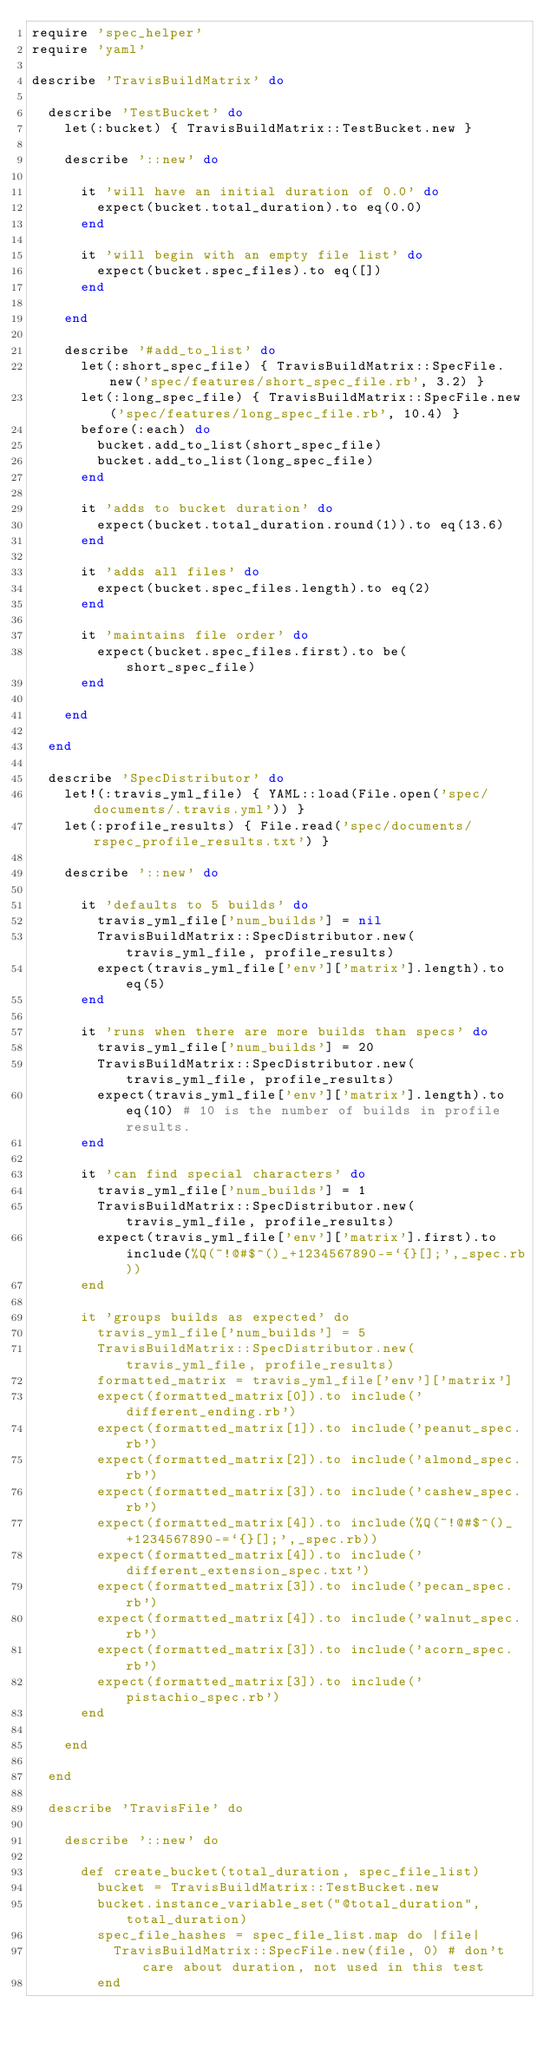<code> <loc_0><loc_0><loc_500><loc_500><_Ruby_>require 'spec_helper'
require 'yaml'

describe 'TravisBuildMatrix' do

  describe 'TestBucket' do
    let(:bucket) { TravisBuildMatrix::TestBucket.new }

    describe '::new' do

      it 'will have an initial duration of 0.0' do
        expect(bucket.total_duration).to eq(0.0)
      end

      it 'will begin with an empty file list' do
        expect(bucket.spec_files).to eq([])
      end

    end

    describe '#add_to_list' do
      let(:short_spec_file) { TravisBuildMatrix::SpecFile.new('spec/features/short_spec_file.rb', 3.2) }
      let(:long_spec_file) { TravisBuildMatrix::SpecFile.new('spec/features/long_spec_file.rb', 10.4) }
      before(:each) do
        bucket.add_to_list(short_spec_file)
        bucket.add_to_list(long_spec_file)
      end

      it 'adds to bucket duration' do
        expect(bucket.total_duration.round(1)).to eq(13.6)
      end

      it 'adds all files' do
        expect(bucket.spec_files.length).to eq(2)
      end

      it 'maintains file order' do
        expect(bucket.spec_files.first).to be(short_spec_file)
      end

    end

  end

  describe 'SpecDistributor' do
    let!(:travis_yml_file) { YAML::load(File.open('spec/documents/.travis.yml')) }
    let(:profile_results) { File.read('spec/documents/rspec_profile_results.txt') }

    describe '::new' do

      it 'defaults to 5 builds' do
        travis_yml_file['num_builds'] = nil
        TravisBuildMatrix::SpecDistributor.new(travis_yml_file, profile_results)
        expect(travis_yml_file['env']['matrix'].length).to eq(5)
      end

      it 'runs when there are more builds than specs' do
        travis_yml_file['num_builds'] = 20
        TravisBuildMatrix::SpecDistributor.new(travis_yml_file, profile_results)
        expect(travis_yml_file['env']['matrix'].length).to eq(10) # 10 is the number of builds in profile results.
      end

      it 'can find special characters' do
        travis_yml_file['num_builds'] = 1
        TravisBuildMatrix::SpecDistributor.new(travis_yml_file, profile_results)
        expect(travis_yml_file['env']['matrix'].first).to include(%Q(~!@#$^()_+1234567890-=`{}[];',_spec.rb))
      end
      
      it 'groups builds as expected' do
        travis_yml_file['num_builds'] = 5
        TravisBuildMatrix::SpecDistributor.new(travis_yml_file, profile_results)
        formatted_matrix = travis_yml_file['env']['matrix']
        expect(formatted_matrix[0]).to include('different_ending.rb')
        expect(formatted_matrix[1]).to include('peanut_spec.rb')
        expect(formatted_matrix[2]).to include('almond_spec.rb')
        expect(formatted_matrix[3]).to include('cashew_spec.rb')
        expect(formatted_matrix[4]).to include(%Q(~!@#$^()_+1234567890-=`{}[];',_spec.rb))
        expect(formatted_matrix[4]).to include('different_extension_spec.txt')
        expect(formatted_matrix[3]).to include('pecan_spec.rb')
        expect(formatted_matrix[4]).to include('walnut_spec.rb')
        expect(formatted_matrix[3]).to include('acorn_spec.rb')
        expect(formatted_matrix[3]).to include('pistachio_spec.rb')
      end

    end

  end

  describe 'TravisFile' do

    describe '::new' do

      def create_bucket(total_duration, spec_file_list)
        bucket = TravisBuildMatrix::TestBucket.new
        bucket.instance_variable_set("@total_duration", total_duration)
        spec_file_hashes = spec_file_list.map do |file|
          TravisBuildMatrix::SpecFile.new(file, 0) # don't care about duration, not used in this test
        end</code> 